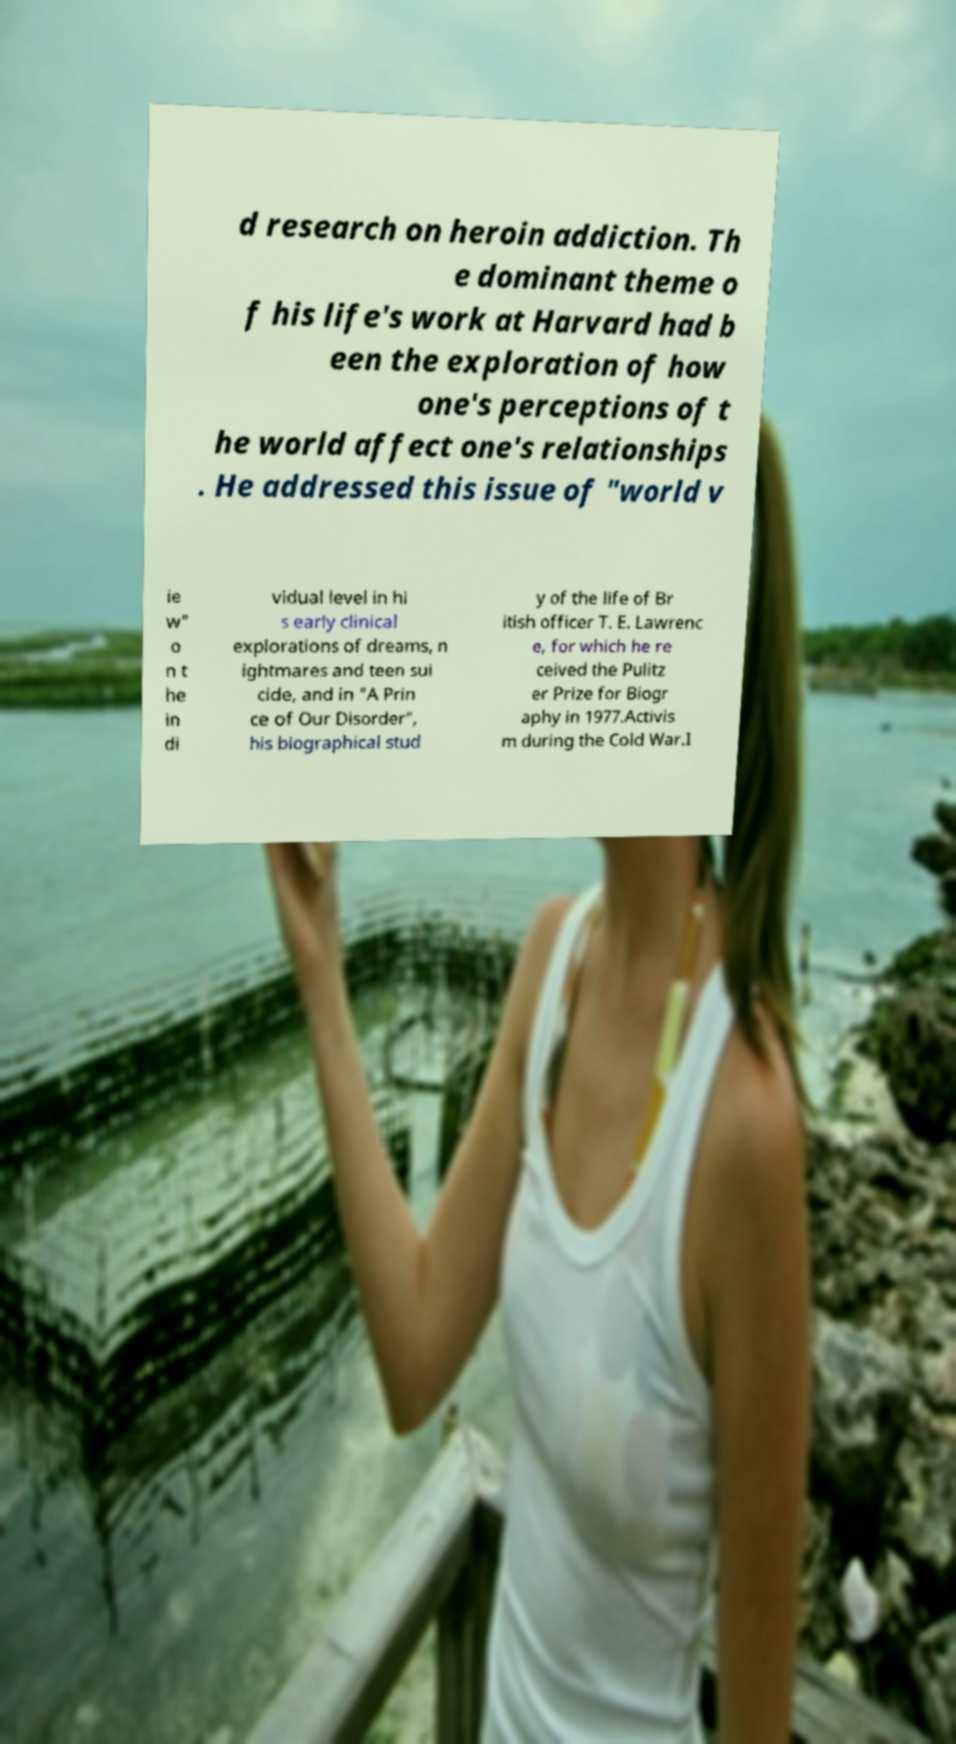For documentation purposes, I need the text within this image transcribed. Could you provide that? d research on heroin addiction. Th e dominant theme o f his life's work at Harvard had b een the exploration of how one's perceptions of t he world affect one's relationships . He addressed this issue of "world v ie w" o n t he in di vidual level in hi s early clinical explorations of dreams, n ightmares and teen sui cide, and in "A Prin ce of Our Disorder", his biographical stud y of the life of Br itish officer T. E. Lawrenc e, for which he re ceived the Pulitz er Prize for Biogr aphy in 1977.Activis m during the Cold War.I 